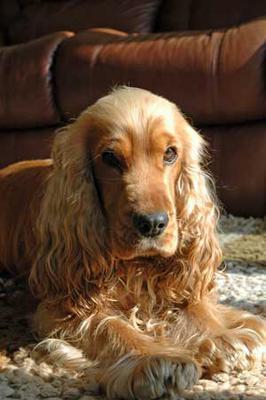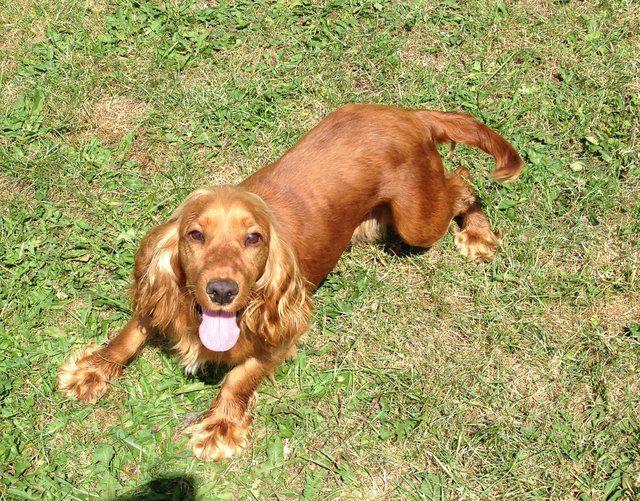The first image is the image on the left, the second image is the image on the right. Considering the images on both sides, is "The dogs in the image on the right are not on grass." valid? Answer yes or no. No. 